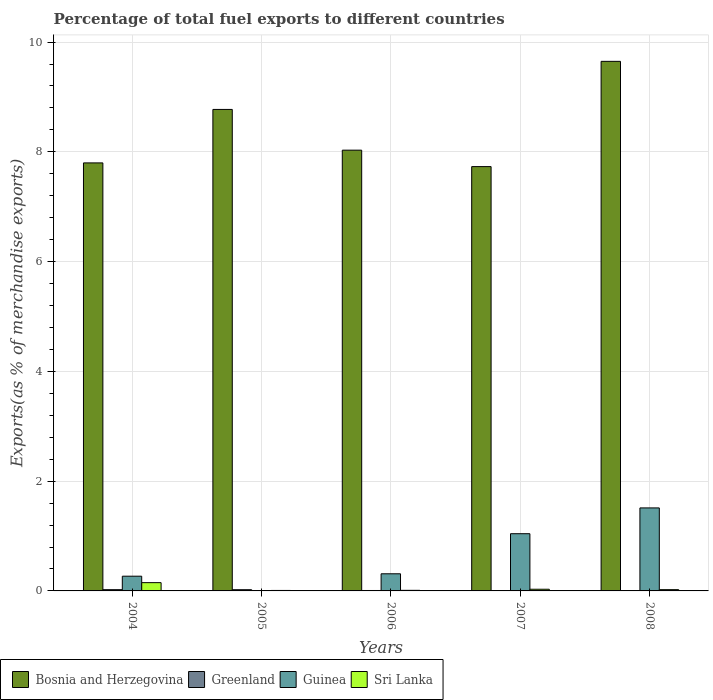How many different coloured bars are there?
Your response must be concise. 4. How many groups of bars are there?
Give a very brief answer. 5. Are the number of bars per tick equal to the number of legend labels?
Give a very brief answer. Yes. Are the number of bars on each tick of the X-axis equal?
Ensure brevity in your answer.  Yes. How many bars are there on the 5th tick from the right?
Ensure brevity in your answer.  4. What is the label of the 2nd group of bars from the left?
Offer a terse response. 2005. In how many cases, is the number of bars for a given year not equal to the number of legend labels?
Offer a very short reply. 0. What is the percentage of exports to different countries in Bosnia and Herzegovina in 2006?
Keep it short and to the point. 8.03. Across all years, what is the maximum percentage of exports to different countries in Bosnia and Herzegovina?
Keep it short and to the point. 9.65. Across all years, what is the minimum percentage of exports to different countries in Sri Lanka?
Provide a short and direct response. 0.01. In which year was the percentage of exports to different countries in Greenland minimum?
Keep it short and to the point. 2007. What is the total percentage of exports to different countries in Greenland in the graph?
Make the answer very short. 0.05. What is the difference between the percentage of exports to different countries in Greenland in 2007 and that in 2008?
Ensure brevity in your answer.  -0. What is the difference between the percentage of exports to different countries in Bosnia and Herzegovina in 2006 and the percentage of exports to different countries in Greenland in 2004?
Your response must be concise. 8.01. What is the average percentage of exports to different countries in Guinea per year?
Ensure brevity in your answer.  0.63. In the year 2005, what is the difference between the percentage of exports to different countries in Bosnia and Herzegovina and percentage of exports to different countries in Greenland?
Make the answer very short. 8.75. What is the ratio of the percentage of exports to different countries in Greenland in 2004 to that in 2005?
Keep it short and to the point. 1.02. Is the percentage of exports to different countries in Guinea in 2005 less than that in 2008?
Provide a short and direct response. Yes. Is the difference between the percentage of exports to different countries in Bosnia and Herzegovina in 2004 and 2006 greater than the difference between the percentage of exports to different countries in Greenland in 2004 and 2006?
Provide a succinct answer. No. What is the difference between the highest and the second highest percentage of exports to different countries in Sri Lanka?
Ensure brevity in your answer.  0.12. What is the difference between the highest and the lowest percentage of exports to different countries in Sri Lanka?
Ensure brevity in your answer.  0.14. In how many years, is the percentage of exports to different countries in Greenland greater than the average percentage of exports to different countries in Greenland taken over all years?
Keep it short and to the point. 2. Is the sum of the percentage of exports to different countries in Guinea in 2006 and 2008 greater than the maximum percentage of exports to different countries in Bosnia and Herzegovina across all years?
Your answer should be compact. No. Is it the case that in every year, the sum of the percentage of exports to different countries in Bosnia and Herzegovina and percentage of exports to different countries in Greenland is greater than the sum of percentage of exports to different countries in Sri Lanka and percentage of exports to different countries in Guinea?
Your answer should be compact. Yes. What does the 1st bar from the left in 2006 represents?
Provide a short and direct response. Bosnia and Herzegovina. What does the 3rd bar from the right in 2008 represents?
Provide a succinct answer. Greenland. Is it the case that in every year, the sum of the percentage of exports to different countries in Sri Lanka and percentage of exports to different countries in Bosnia and Herzegovina is greater than the percentage of exports to different countries in Greenland?
Make the answer very short. Yes. Are all the bars in the graph horizontal?
Provide a succinct answer. No. Are the values on the major ticks of Y-axis written in scientific E-notation?
Offer a very short reply. No. Does the graph contain any zero values?
Give a very brief answer. No. Where does the legend appear in the graph?
Your answer should be compact. Bottom left. How are the legend labels stacked?
Make the answer very short. Horizontal. What is the title of the graph?
Provide a short and direct response. Percentage of total fuel exports to different countries. What is the label or title of the X-axis?
Make the answer very short. Years. What is the label or title of the Y-axis?
Offer a very short reply. Exports(as % of merchandise exports). What is the Exports(as % of merchandise exports) in Bosnia and Herzegovina in 2004?
Offer a terse response. 7.8. What is the Exports(as % of merchandise exports) of Greenland in 2004?
Your response must be concise. 0.02. What is the Exports(as % of merchandise exports) in Guinea in 2004?
Provide a succinct answer. 0.27. What is the Exports(as % of merchandise exports) in Sri Lanka in 2004?
Your response must be concise. 0.15. What is the Exports(as % of merchandise exports) of Bosnia and Herzegovina in 2005?
Provide a short and direct response. 8.77. What is the Exports(as % of merchandise exports) of Greenland in 2005?
Make the answer very short. 0.02. What is the Exports(as % of merchandise exports) in Guinea in 2005?
Offer a terse response. 3.9069582544466e-5. What is the Exports(as % of merchandise exports) in Sri Lanka in 2005?
Your response must be concise. 0.01. What is the Exports(as % of merchandise exports) of Bosnia and Herzegovina in 2006?
Make the answer very short. 8.03. What is the Exports(as % of merchandise exports) in Greenland in 2006?
Keep it short and to the point. 0.01. What is the Exports(as % of merchandise exports) in Guinea in 2006?
Your answer should be very brief. 0.31. What is the Exports(as % of merchandise exports) of Sri Lanka in 2006?
Your response must be concise. 0.01. What is the Exports(as % of merchandise exports) of Bosnia and Herzegovina in 2007?
Your response must be concise. 7.73. What is the Exports(as % of merchandise exports) of Greenland in 2007?
Give a very brief answer. 1.67003405452262e-5. What is the Exports(as % of merchandise exports) in Guinea in 2007?
Your response must be concise. 1.04. What is the Exports(as % of merchandise exports) of Sri Lanka in 2007?
Your answer should be very brief. 0.03. What is the Exports(as % of merchandise exports) in Bosnia and Herzegovina in 2008?
Give a very brief answer. 9.65. What is the Exports(as % of merchandise exports) in Greenland in 2008?
Your answer should be compact. 0. What is the Exports(as % of merchandise exports) of Guinea in 2008?
Ensure brevity in your answer.  1.51. What is the Exports(as % of merchandise exports) of Sri Lanka in 2008?
Your response must be concise. 0.02. Across all years, what is the maximum Exports(as % of merchandise exports) of Bosnia and Herzegovina?
Make the answer very short. 9.65. Across all years, what is the maximum Exports(as % of merchandise exports) of Greenland?
Offer a very short reply. 0.02. Across all years, what is the maximum Exports(as % of merchandise exports) in Guinea?
Provide a short and direct response. 1.51. Across all years, what is the maximum Exports(as % of merchandise exports) in Sri Lanka?
Ensure brevity in your answer.  0.15. Across all years, what is the minimum Exports(as % of merchandise exports) of Bosnia and Herzegovina?
Provide a succinct answer. 7.73. Across all years, what is the minimum Exports(as % of merchandise exports) of Greenland?
Your response must be concise. 1.67003405452262e-5. Across all years, what is the minimum Exports(as % of merchandise exports) in Guinea?
Ensure brevity in your answer.  3.9069582544466e-5. Across all years, what is the minimum Exports(as % of merchandise exports) in Sri Lanka?
Make the answer very short. 0.01. What is the total Exports(as % of merchandise exports) of Bosnia and Herzegovina in the graph?
Your answer should be very brief. 41.98. What is the total Exports(as % of merchandise exports) in Greenland in the graph?
Offer a terse response. 0.05. What is the total Exports(as % of merchandise exports) in Guinea in the graph?
Ensure brevity in your answer.  3.14. What is the total Exports(as % of merchandise exports) of Sri Lanka in the graph?
Ensure brevity in your answer.  0.22. What is the difference between the Exports(as % of merchandise exports) in Bosnia and Herzegovina in 2004 and that in 2005?
Your response must be concise. -0.97. What is the difference between the Exports(as % of merchandise exports) in Guinea in 2004 and that in 2005?
Your answer should be compact. 0.27. What is the difference between the Exports(as % of merchandise exports) of Sri Lanka in 2004 and that in 2005?
Make the answer very short. 0.14. What is the difference between the Exports(as % of merchandise exports) in Bosnia and Herzegovina in 2004 and that in 2006?
Offer a very short reply. -0.23. What is the difference between the Exports(as % of merchandise exports) in Greenland in 2004 and that in 2006?
Offer a terse response. 0.01. What is the difference between the Exports(as % of merchandise exports) of Guinea in 2004 and that in 2006?
Your response must be concise. -0.04. What is the difference between the Exports(as % of merchandise exports) of Sri Lanka in 2004 and that in 2006?
Ensure brevity in your answer.  0.14. What is the difference between the Exports(as % of merchandise exports) of Bosnia and Herzegovina in 2004 and that in 2007?
Make the answer very short. 0.07. What is the difference between the Exports(as % of merchandise exports) in Greenland in 2004 and that in 2007?
Offer a very short reply. 0.02. What is the difference between the Exports(as % of merchandise exports) of Guinea in 2004 and that in 2007?
Give a very brief answer. -0.77. What is the difference between the Exports(as % of merchandise exports) in Sri Lanka in 2004 and that in 2007?
Ensure brevity in your answer.  0.12. What is the difference between the Exports(as % of merchandise exports) of Bosnia and Herzegovina in 2004 and that in 2008?
Offer a very short reply. -1.85. What is the difference between the Exports(as % of merchandise exports) of Greenland in 2004 and that in 2008?
Offer a terse response. 0.02. What is the difference between the Exports(as % of merchandise exports) of Guinea in 2004 and that in 2008?
Your answer should be compact. -1.24. What is the difference between the Exports(as % of merchandise exports) of Sri Lanka in 2004 and that in 2008?
Your response must be concise. 0.13. What is the difference between the Exports(as % of merchandise exports) of Bosnia and Herzegovina in 2005 and that in 2006?
Give a very brief answer. 0.74. What is the difference between the Exports(as % of merchandise exports) of Greenland in 2005 and that in 2006?
Give a very brief answer. 0.01. What is the difference between the Exports(as % of merchandise exports) of Guinea in 2005 and that in 2006?
Provide a succinct answer. -0.31. What is the difference between the Exports(as % of merchandise exports) in Sri Lanka in 2005 and that in 2006?
Make the answer very short. -0. What is the difference between the Exports(as % of merchandise exports) of Bosnia and Herzegovina in 2005 and that in 2007?
Ensure brevity in your answer.  1.04. What is the difference between the Exports(as % of merchandise exports) in Greenland in 2005 and that in 2007?
Offer a very short reply. 0.02. What is the difference between the Exports(as % of merchandise exports) in Guinea in 2005 and that in 2007?
Your answer should be compact. -1.04. What is the difference between the Exports(as % of merchandise exports) of Sri Lanka in 2005 and that in 2007?
Provide a short and direct response. -0.02. What is the difference between the Exports(as % of merchandise exports) of Bosnia and Herzegovina in 2005 and that in 2008?
Keep it short and to the point. -0.88. What is the difference between the Exports(as % of merchandise exports) of Greenland in 2005 and that in 2008?
Provide a succinct answer. 0.02. What is the difference between the Exports(as % of merchandise exports) in Guinea in 2005 and that in 2008?
Your response must be concise. -1.51. What is the difference between the Exports(as % of merchandise exports) of Sri Lanka in 2005 and that in 2008?
Make the answer very short. -0.01. What is the difference between the Exports(as % of merchandise exports) in Bosnia and Herzegovina in 2006 and that in 2007?
Offer a very short reply. 0.3. What is the difference between the Exports(as % of merchandise exports) in Greenland in 2006 and that in 2007?
Offer a very short reply. 0.01. What is the difference between the Exports(as % of merchandise exports) of Guinea in 2006 and that in 2007?
Give a very brief answer. -0.73. What is the difference between the Exports(as % of merchandise exports) in Sri Lanka in 2006 and that in 2007?
Keep it short and to the point. -0.02. What is the difference between the Exports(as % of merchandise exports) in Bosnia and Herzegovina in 2006 and that in 2008?
Offer a very short reply. -1.62. What is the difference between the Exports(as % of merchandise exports) in Greenland in 2006 and that in 2008?
Ensure brevity in your answer.  0.01. What is the difference between the Exports(as % of merchandise exports) of Guinea in 2006 and that in 2008?
Offer a terse response. -1.2. What is the difference between the Exports(as % of merchandise exports) of Sri Lanka in 2006 and that in 2008?
Your response must be concise. -0.01. What is the difference between the Exports(as % of merchandise exports) in Bosnia and Herzegovina in 2007 and that in 2008?
Offer a very short reply. -1.92. What is the difference between the Exports(as % of merchandise exports) of Greenland in 2007 and that in 2008?
Keep it short and to the point. -0. What is the difference between the Exports(as % of merchandise exports) of Guinea in 2007 and that in 2008?
Your response must be concise. -0.47. What is the difference between the Exports(as % of merchandise exports) in Sri Lanka in 2007 and that in 2008?
Your answer should be very brief. 0.01. What is the difference between the Exports(as % of merchandise exports) of Bosnia and Herzegovina in 2004 and the Exports(as % of merchandise exports) of Greenland in 2005?
Your answer should be very brief. 7.78. What is the difference between the Exports(as % of merchandise exports) in Bosnia and Herzegovina in 2004 and the Exports(as % of merchandise exports) in Guinea in 2005?
Offer a terse response. 7.8. What is the difference between the Exports(as % of merchandise exports) of Bosnia and Herzegovina in 2004 and the Exports(as % of merchandise exports) of Sri Lanka in 2005?
Provide a succinct answer. 7.79. What is the difference between the Exports(as % of merchandise exports) of Greenland in 2004 and the Exports(as % of merchandise exports) of Guinea in 2005?
Keep it short and to the point. 0.02. What is the difference between the Exports(as % of merchandise exports) of Greenland in 2004 and the Exports(as % of merchandise exports) of Sri Lanka in 2005?
Your answer should be compact. 0.01. What is the difference between the Exports(as % of merchandise exports) in Guinea in 2004 and the Exports(as % of merchandise exports) in Sri Lanka in 2005?
Ensure brevity in your answer.  0.26. What is the difference between the Exports(as % of merchandise exports) in Bosnia and Herzegovina in 2004 and the Exports(as % of merchandise exports) in Greenland in 2006?
Give a very brief answer. 7.79. What is the difference between the Exports(as % of merchandise exports) of Bosnia and Herzegovina in 2004 and the Exports(as % of merchandise exports) of Guinea in 2006?
Your answer should be very brief. 7.49. What is the difference between the Exports(as % of merchandise exports) in Bosnia and Herzegovina in 2004 and the Exports(as % of merchandise exports) in Sri Lanka in 2006?
Ensure brevity in your answer.  7.79. What is the difference between the Exports(as % of merchandise exports) in Greenland in 2004 and the Exports(as % of merchandise exports) in Guinea in 2006?
Offer a very short reply. -0.29. What is the difference between the Exports(as % of merchandise exports) of Greenland in 2004 and the Exports(as % of merchandise exports) of Sri Lanka in 2006?
Make the answer very short. 0.01. What is the difference between the Exports(as % of merchandise exports) in Guinea in 2004 and the Exports(as % of merchandise exports) in Sri Lanka in 2006?
Offer a terse response. 0.26. What is the difference between the Exports(as % of merchandise exports) in Bosnia and Herzegovina in 2004 and the Exports(as % of merchandise exports) in Greenland in 2007?
Offer a terse response. 7.8. What is the difference between the Exports(as % of merchandise exports) in Bosnia and Herzegovina in 2004 and the Exports(as % of merchandise exports) in Guinea in 2007?
Provide a succinct answer. 6.76. What is the difference between the Exports(as % of merchandise exports) in Bosnia and Herzegovina in 2004 and the Exports(as % of merchandise exports) in Sri Lanka in 2007?
Offer a terse response. 7.77. What is the difference between the Exports(as % of merchandise exports) of Greenland in 2004 and the Exports(as % of merchandise exports) of Guinea in 2007?
Make the answer very short. -1.02. What is the difference between the Exports(as % of merchandise exports) of Greenland in 2004 and the Exports(as % of merchandise exports) of Sri Lanka in 2007?
Provide a short and direct response. -0.01. What is the difference between the Exports(as % of merchandise exports) of Guinea in 2004 and the Exports(as % of merchandise exports) of Sri Lanka in 2007?
Offer a very short reply. 0.24. What is the difference between the Exports(as % of merchandise exports) in Bosnia and Herzegovina in 2004 and the Exports(as % of merchandise exports) in Greenland in 2008?
Ensure brevity in your answer.  7.8. What is the difference between the Exports(as % of merchandise exports) in Bosnia and Herzegovina in 2004 and the Exports(as % of merchandise exports) in Guinea in 2008?
Ensure brevity in your answer.  6.29. What is the difference between the Exports(as % of merchandise exports) of Bosnia and Herzegovina in 2004 and the Exports(as % of merchandise exports) of Sri Lanka in 2008?
Give a very brief answer. 7.78. What is the difference between the Exports(as % of merchandise exports) in Greenland in 2004 and the Exports(as % of merchandise exports) in Guinea in 2008?
Make the answer very short. -1.49. What is the difference between the Exports(as % of merchandise exports) of Greenland in 2004 and the Exports(as % of merchandise exports) of Sri Lanka in 2008?
Keep it short and to the point. -0. What is the difference between the Exports(as % of merchandise exports) of Guinea in 2004 and the Exports(as % of merchandise exports) of Sri Lanka in 2008?
Offer a very short reply. 0.25. What is the difference between the Exports(as % of merchandise exports) of Bosnia and Herzegovina in 2005 and the Exports(as % of merchandise exports) of Greenland in 2006?
Offer a terse response. 8.77. What is the difference between the Exports(as % of merchandise exports) of Bosnia and Herzegovina in 2005 and the Exports(as % of merchandise exports) of Guinea in 2006?
Offer a very short reply. 8.46. What is the difference between the Exports(as % of merchandise exports) in Bosnia and Herzegovina in 2005 and the Exports(as % of merchandise exports) in Sri Lanka in 2006?
Offer a terse response. 8.76. What is the difference between the Exports(as % of merchandise exports) of Greenland in 2005 and the Exports(as % of merchandise exports) of Guinea in 2006?
Provide a succinct answer. -0.29. What is the difference between the Exports(as % of merchandise exports) in Greenland in 2005 and the Exports(as % of merchandise exports) in Sri Lanka in 2006?
Make the answer very short. 0.01. What is the difference between the Exports(as % of merchandise exports) in Guinea in 2005 and the Exports(as % of merchandise exports) in Sri Lanka in 2006?
Provide a short and direct response. -0.01. What is the difference between the Exports(as % of merchandise exports) of Bosnia and Herzegovina in 2005 and the Exports(as % of merchandise exports) of Greenland in 2007?
Ensure brevity in your answer.  8.77. What is the difference between the Exports(as % of merchandise exports) in Bosnia and Herzegovina in 2005 and the Exports(as % of merchandise exports) in Guinea in 2007?
Provide a short and direct response. 7.73. What is the difference between the Exports(as % of merchandise exports) of Bosnia and Herzegovina in 2005 and the Exports(as % of merchandise exports) of Sri Lanka in 2007?
Give a very brief answer. 8.74. What is the difference between the Exports(as % of merchandise exports) of Greenland in 2005 and the Exports(as % of merchandise exports) of Guinea in 2007?
Provide a succinct answer. -1.02. What is the difference between the Exports(as % of merchandise exports) in Greenland in 2005 and the Exports(as % of merchandise exports) in Sri Lanka in 2007?
Keep it short and to the point. -0.01. What is the difference between the Exports(as % of merchandise exports) of Guinea in 2005 and the Exports(as % of merchandise exports) of Sri Lanka in 2007?
Provide a short and direct response. -0.03. What is the difference between the Exports(as % of merchandise exports) of Bosnia and Herzegovina in 2005 and the Exports(as % of merchandise exports) of Greenland in 2008?
Provide a short and direct response. 8.77. What is the difference between the Exports(as % of merchandise exports) in Bosnia and Herzegovina in 2005 and the Exports(as % of merchandise exports) in Guinea in 2008?
Ensure brevity in your answer.  7.26. What is the difference between the Exports(as % of merchandise exports) of Bosnia and Herzegovina in 2005 and the Exports(as % of merchandise exports) of Sri Lanka in 2008?
Ensure brevity in your answer.  8.75. What is the difference between the Exports(as % of merchandise exports) of Greenland in 2005 and the Exports(as % of merchandise exports) of Guinea in 2008?
Provide a succinct answer. -1.49. What is the difference between the Exports(as % of merchandise exports) of Greenland in 2005 and the Exports(as % of merchandise exports) of Sri Lanka in 2008?
Make the answer very short. -0. What is the difference between the Exports(as % of merchandise exports) of Guinea in 2005 and the Exports(as % of merchandise exports) of Sri Lanka in 2008?
Offer a terse response. -0.02. What is the difference between the Exports(as % of merchandise exports) in Bosnia and Herzegovina in 2006 and the Exports(as % of merchandise exports) in Greenland in 2007?
Make the answer very short. 8.03. What is the difference between the Exports(as % of merchandise exports) of Bosnia and Herzegovina in 2006 and the Exports(as % of merchandise exports) of Guinea in 2007?
Your answer should be compact. 6.99. What is the difference between the Exports(as % of merchandise exports) of Bosnia and Herzegovina in 2006 and the Exports(as % of merchandise exports) of Sri Lanka in 2007?
Offer a terse response. 8. What is the difference between the Exports(as % of merchandise exports) of Greenland in 2006 and the Exports(as % of merchandise exports) of Guinea in 2007?
Your response must be concise. -1.03. What is the difference between the Exports(as % of merchandise exports) of Greenland in 2006 and the Exports(as % of merchandise exports) of Sri Lanka in 2007?
Your answer should be very brief. -0.02. What is the difference between the Exports(as % of merchandise exports) in Guinea in 2006 and the Exports(as % of merchandise exports) in Sri Lanka in 2007?
Your answer should be very brief. 0.28. What is the difference between the Exports(as % of merchandise exports) of Bosnia and Herzegovina in 2006 and the Exports(as % of merchandise exports) of Greenland in 2008?
Make the answer very short. 8.03. What is the difference between the Exports(as % of merchandise exports) of Bosnia and Herzegovina in 2006 and the Exports(as % of merchandise exports) of Guinea in 2008?
Provide a short and direct response. 6.52. What is the difference between the Exports(as % of merchandise exports) of Bosnia and Herzegovina in 2006 and the Exports(as % of merchandise exports) of Sri Lanka in 2008?
Your answer should be compact. 8.01. What is the difference between the Exports(as % of merchandise exports) in Greenland in 2006 and the Exports(as % of merchandise exports) in Guinea in 2008?
Give a very brief answer. -1.5. What is the difference between the Exports(as % of merchandise exports) in Greenland in 2006 and the Exports(as % of merchandise exports) in Sri Lanka in 2008?
Your answer should be compact. -0.02. What is the difference between the Exports(as % of merchandise exports) in Guinea in 2006 and the Exports(as % of merchandise exports) in Sri Lanka in 2008?
Provide a succinct answer. 0.29. What is the difference between the Exports(as % of merchandise exports) of Bosnia and Herzegovina in 2007 and the Exports(as % of merchandise exports) of Greenland in 2008?
Keep it short and to the point. 7.73. What is the difference between the Exports(as % of merchandise exports) of Bosnia and Herzegovina in 2007 and the Exports(as % of merchandise exports) of Guinea in 2008?
Make the answer very short. 6.22. What is the difference between the Exports(as % of merchandise exports) in Bosnia and Herzegovina in 2007 and the Exports(as % of merchandise exports) in Sri Lanka in 2008?
Give a very brief answer. 7.71. What is the difference between the Exports(as % of merchandise exports) of Greenland in 2007 and the Exports(as % of merchandise exports) of Guinea in 2008?
Your answer should be compact. -1.51. What is the difference between the Exports(as % of merchandise exports) in Greenland in 2007 and the Exports(as % of merchandise exports) in Sri Lanka in 2008?
Keep it short and to the point. -0.02. What is the difference between the Exports(as % of merchandise exports) in Guinea in 2007 and the Exports(as % of merchandise exports) in Sri Lanka in 2008?
Provide a short and direct response. 1.02. What is the average Exports(as % of merchandise exports) in Bosnia and Herzegovina per year?
Make the answer very short. 8.4. What is the average Exports(as % of merchandise exports) in Greenland per year?
Provide a short and direct response. 0.01. What is the average Exports(as % of merchandise exports) of Guinea per year?
Your answer should be compact. 0.63. What is the average Exports(as % of merchandise exports) of Sri Lanka per year?
Make the answer very short. 0.04. In the year 2004, what is the difference between the Exports(as % of merchandise exports) in Bosnia and Herzegovina and Exports(as % of merchandise exports) in Greenland?
Keep it short and to the point. 7.78. In the year 2004, what is the difference between the Exports(as % of merchandise exports) of Bosnia and Herzegovina and Exports(as % of merchandise exports) of Guinea?
Your answer should be compact. 7.53. In the year 2004, what is the difference between the Exports(as % of merchandise exports) of Bosnia and Herzegovina and Exports(as % of merchandise exports) of Sri Lanka?
Ensure brevity in your answer.  7.65. In the year 2004, what is the difference between the Exports(as % of merchandise exports) in Greenland and Exports(as % of merchandise exports) in Guinea?
Ensure brevity in your answer.  -0.25. In the year 2004, what is the difference between the Exports(as % of merchandise exports) of Greenland and Exports(as % of merchandise exports) of Sri Lanka?
Your response must be concise. -0.13. In the year 2004, what is the difference between the Exports(as % of merchandise exports) in Guinea and Exports(as % of merchandise exports) in Sri Lanka?
Offer a very short reply. 0.12. In the year 2005, what is the difference between the Exports(as % of merchandise exports) in Bosnia and Herzegovina and Exports(as % of merchandise exports) in Greenland?
Your answer should be very brief. 8.75. In the year 2005, what is the difference between the Exports(as % of merchandise exports) in Bosnia and Herzegovina and Exports(as % of merchandise exports) in Guinea?
Your answer should be compact. 8.77. In the year 2005, what is the difference between the Exports(as % of merchandise exports) of Bosnia and Herzegovina and Exports(as % of merchandise exports) of Sri Lanka?
Your response must be concise. 8.76. In the year 2005, what is the difference between the Exports(as % of merchandise exports) in Greenland and Exports(as % of merchandise exports) in Guinea?
Give a very brief answer. 0.02. In the year 2005, what is the difference between the Exports(as % of merchandise exports) in Greenland and Exports(as % of merchandise exports) in Sri Lanka?
Make the answer very short. 0.01. In the year 2005, what is the difference between the Exports(as % of merchandise exports) in Guinea and Exports(as % of merchandise exports) in Sri Lanka?
Make the answer very short. -0.01. In the year 2006, what is the difference between the Exports(as % of merchandise exports) of Bosnia and Herzegovina and Exports(as % of merchandise exports) of Greenland?
Give a very brief answer. 8.02. In the year 2006, what is the difference between the Exports(as % of merchandise exports) of Bosnia and Herzegovina and Exports(as % of merchandise exports) of Guinea?
Provide a short and direct response. 7.72. In the year 2006, what is the difference between the Exports(as % of merchandise exports) of Bosnia and Herzegovina and Exports(as % of merchandise exports) of Sri Lanka?
Your response must be concise. 8.02. In the year 2006, what is the difference between the Exports(as % of merchandise exports) in Greenland and Exports(as % of merchandise exports) in Guinea?
Ensure brevity in your answer.  -0.3. In the year 2006, what is the difference between the Exports(as % of merchandise exports) in Greenland and Exports(as % of merchandise exports) in Sri Lanka?
Your answer should be compact. -0. In the year 2006, what is the difference between the Exports(as % of merchandise exports) in Guinea and Exports(as % of merchandise exports) in Sri Lanka?
Keep it short and to the point. 0.3. In the year 2007, what is the difference between the Exports(as % of merchandise exports) of Bosnia and Herzegovina and Exports(as % of merchandise exports) of Greenland?
Keep it short and to the point. 7.73. In the year 2007, what is the difference between the Exports(as % of merchandise exports) in Bosnia and Herzegovina and Exports(as % of merchandise exports) in Guinea?
Your answer should be compact. 6.69. In the year 2007, what is the difference between the Exports(as % of merchandise exports) of Bosnia and Herzegovina and Exports(as % of merchandise exports) of Sri Lanka?
Make the answer very short. 7.7. In the year 2007, what is the difference between the Exports(as % of merchandise exports) of Greenland and Exports(as % of merchandise exports) of Guinea?
Offer a terse response. -1.04. In the year 2007, what is the difference between the Exports(as % of merchandise exports) in Greenland and Exports(as % of merchandise exports) in Sri Lanka?
Your response must be concise. -0.03. In the year 2008, what is the difference between the Exports(as % of merchandise exports) of Bosnia and Herzegovina and Exports(as % of merchandise exports) of Greenland?
Keep it short and to the point. 9.65. In the year 2008, what is the difference between the Exports(as % of merchandise exports) in Bosnia and Herzegovina and Exports(as % of merchandise exports) in Guinea?
Provide a short and direct response. 8.14. In the year 2008, what is the difference between the Exports(as % of merchandise exports) of Bosnia and Herzegovina and Exports(as % of merchandise exports) of Sri Lanka?
Your answer should be compact. 9.63. In the year 2008, what is the difference between the Exports(as % of merchandise exports) of Greenland and Exports(as % of merchandise exports) of Guinea?
Your response must be concise. -1.51. In the year 2008, what is the difference between the Exports(as % of merchandise exports) in Greenland and Exports(as % of merchandise exports) in Sri Lanka?
Provide a short and direct response. -0.02. In the year 2008, what is the difference between the Exports(as % of merchandise exports) in Guinea and Exports(as % of merchandise exports) in Sri Lanka?
Ensure brevity in your answer.  1.49. What is the ratio of the Exports(as % of merchandise exports) in Bosnia and Herzegovina in 2004 to that in 2005?
Offer a very short reply. 0.89. What is the ratio of the Exports(as % of merchandise exports) in Greenland in 2004 to that in 2005?
Your answer should be very brief. 1.02. What is the ratio of the Exports(as % of merchandise exports) of Guinea in 2004 to that in 2005?
Make the answer very short. 6866.83. What is the ratio of the Exports(as % of merchandise exports) in Sri Lanka in 2004 to that in 2005?
Provide a short and direct response. 17.45. What is the ratio of the Exports(as % of merchandise exports) in Bosnia and Herzegovina in 2004 to that in 2006?
Your answer should be very brief. 0.97. What is the ratio of the Exports(as % of merchandise exports) in Greenland in 2004 to that in 2006?
Your response must be concise. 2.93. What is the ratio of the Exports(as % of merchandise exports) of Guinea in 2004 to that in 2006?
Offer a terse response. 0.86. What is the ratio of the Exports(as % of merchandise exports) in Sri Lanka in 2004 to that in 2006?
Your response must be concise. 13.97. What is the ratio of the Exports(as % of merchandise exports) of Bosnia and Herzegovina in 2004 to that in 2007?
Ensure brevity in your answer.  1.01. What is the ratio of the Exports(as % of merchandise exports) in Greenland in 2004 to that in 2007?
Keep it short and to the point. 1358.12. What is the ratio of the Exports(as % of merchandise exports) of Guinea in 2004 to that in 2007?
Provide a succinct answer. 0.26. What is the ratio of the Exports(as % of merchandise exports) of Sri Lanka in 2004 to that in 2007?
Your answer should be compact. 4.94. What is the ratio of the Exports(as % of merchandise exports) in Bosnia and Herzegovina in 2004 to that in 2008?
Offer a terse response. 0.81. What is the ratio of the Exports(as % of merchandise exports) of Greenland in 2004 to that in 2008?
Make the answer very short. 67.25. What is the ratio of the Exports(as % of merchandise exports) in Guinea in 2004 to that in 2008?
Make the answer very short. 0.18. What is the ratio of the Exports(as % of merchandise exports) of Sri Lanka in 2004 to that in 2008?
Your answer should be compact. 6.53. What is the ratio of the Exports(as % of merchandise exports) of Bosnia and Herzegovina in 2005 to that in 2006?
Provide a succinct answer. 1.09. What is the ratio of the Exports(as % of merchandise exports) in Greenland in 2005 to that in 2006?
Keep it short and to the point. 2.87. What is the ratio of the Exports(as % of merchandise exports) of Guinea in 2005 to that in 2006?
Your answer should be very brief. 0. What is the ratio of the Exports(as % of merchandise exports) in Sri Lanka in 2005 to that in 2006?
Your answer should be compact. 0.8. What is the ratio of the Exports(as % of merchandise exports) of Bosnia and Herzegovina in 2005 to that in 2007?
Make the answer very short. 1.13. What is the ratio of the Exports(as % of merchandise exports) of Greenland in 2005 to that in 2007?
Your answer should be very brief. 1327.28. What is the ratio of the Exports(as % of merchandise exports) of Guinea in 2005 to that in 2007?
Provide a succinct answer. 0. What is the ratio of the Exports(as % of merchandise exports) in Sri Lanka in 2005 to that in 2007?
Offer a terse response. 0.28. What is the ratio of the Exports(as % of merchandise exports) of Bosnia and Herzegovina in 2005 to that in 2008?
Offer a terse response. 0.91. What is the ratio of the Exports(as % of merchandise exports) in Greenland in 2005 to that in 2008?
Your answer should be compact. 65.73. What is the ratio of the Exports(as % of merchandise exports) of Guinea in 2005 to that in 2008?
Provide a short and direct response. 0. What is the ratio of the Exports(as % of merchandise exports) in Sri Lanka in 2005 to that in 2008?
Your response must be concise. 0.37. What is the ratio of the Exports(as % of merchandise exports) in Bosnia and Herzegovina in 2006 to that in 2007?
Your response must be concise. 1.04. What is the ratio of the Exports(as % of merchandise exports) of Greenland in 2006 to that in 2007?
Your answer should be compact. 462.76. What is the ratio of the Exports(as % of merchandise exports) of Guinea in 2006 to that in 2007?
Your response must be concise. 0.3. What is the ratio of the Exports(as % of merchandise exports) of Sri Lanka in 2006 to that in 2007?
Provide a short and direct response. 0.35. What is the ratio of the Exports(as % of merchandise exports) of Bosnia and Herzegovina in 2006 to that in 2008?
Ensure brevity in your answer.  0.83. What is the ratio of the Exports(as % of merchandise exports) in Greenland in 2006 to that in 2008?
Keep it short and to the point. 22.92. What is the ratio of the Exports(as % of merchandise exports) of Guinea in 2006 to that in 2008?
Your answer should be compact. 0.21. What is the ratio of the Exports(as % of merchandise exports) of Sri Lanka in 2006 to that in 2008?
Provide a short and direct response. 0.47. What is the ratio of the Exports(as % of merchandise exports) in Bosnia and Herzegovina in 2007 to that in 2008?
Provide a short and direct response. 0.8. What is the ratio of the Exports(as % of merchandise exports) of Greenland in 2007 to that in 2008?
Offer a very short reply. 0.05. What is the ratio of the Exports(as % of merchandise exports) in Guinea in 2007 to that in 2008?
Keep it short and to the point. 0.69. What is the ratio of the Exports(as % of merchandise exports) of Sri Lanka in 2007 to that in 2008?
Make the answer very short. 1.32. What is the difference between the highest and the second highest Exports(as % of merchandise exports) in Bosnia and Herzegovina?
Provide a short and direct response. 0.88. What is the difference between the highest and the second highest Exports(as % of merchandise exports) in Greenland?
Your answer should be very brief. 0. What is the difference between the highest and the second highest Exports(as % of merchandise exports) of Guinea?
Give a very brief answer. 0.47. What is the difference between the highest and the second highest Exports(as % of merchandise exports) of Sri Lanka?
Keep it short and to the point. 0.12. What is the difference between the highest and the lowest Exports(as % of merchandise exports) of Bosnia and Herzegovina?
Offer a terse response. 1.92. What is the difference between the highest and the lowest Exports(as % of merchandise exports) in Greenland?
Provide a succinct answer. 0.02. What is the difference between the highest and the lowest Exports(as % of merchandise exports) of Guinea?
Make the answer very short. 1.51. What is the difference between the highest and the lowest Exports(as % of merchandise exports) in Sri Lanka?
Keep it short and to the point. 0.14. 